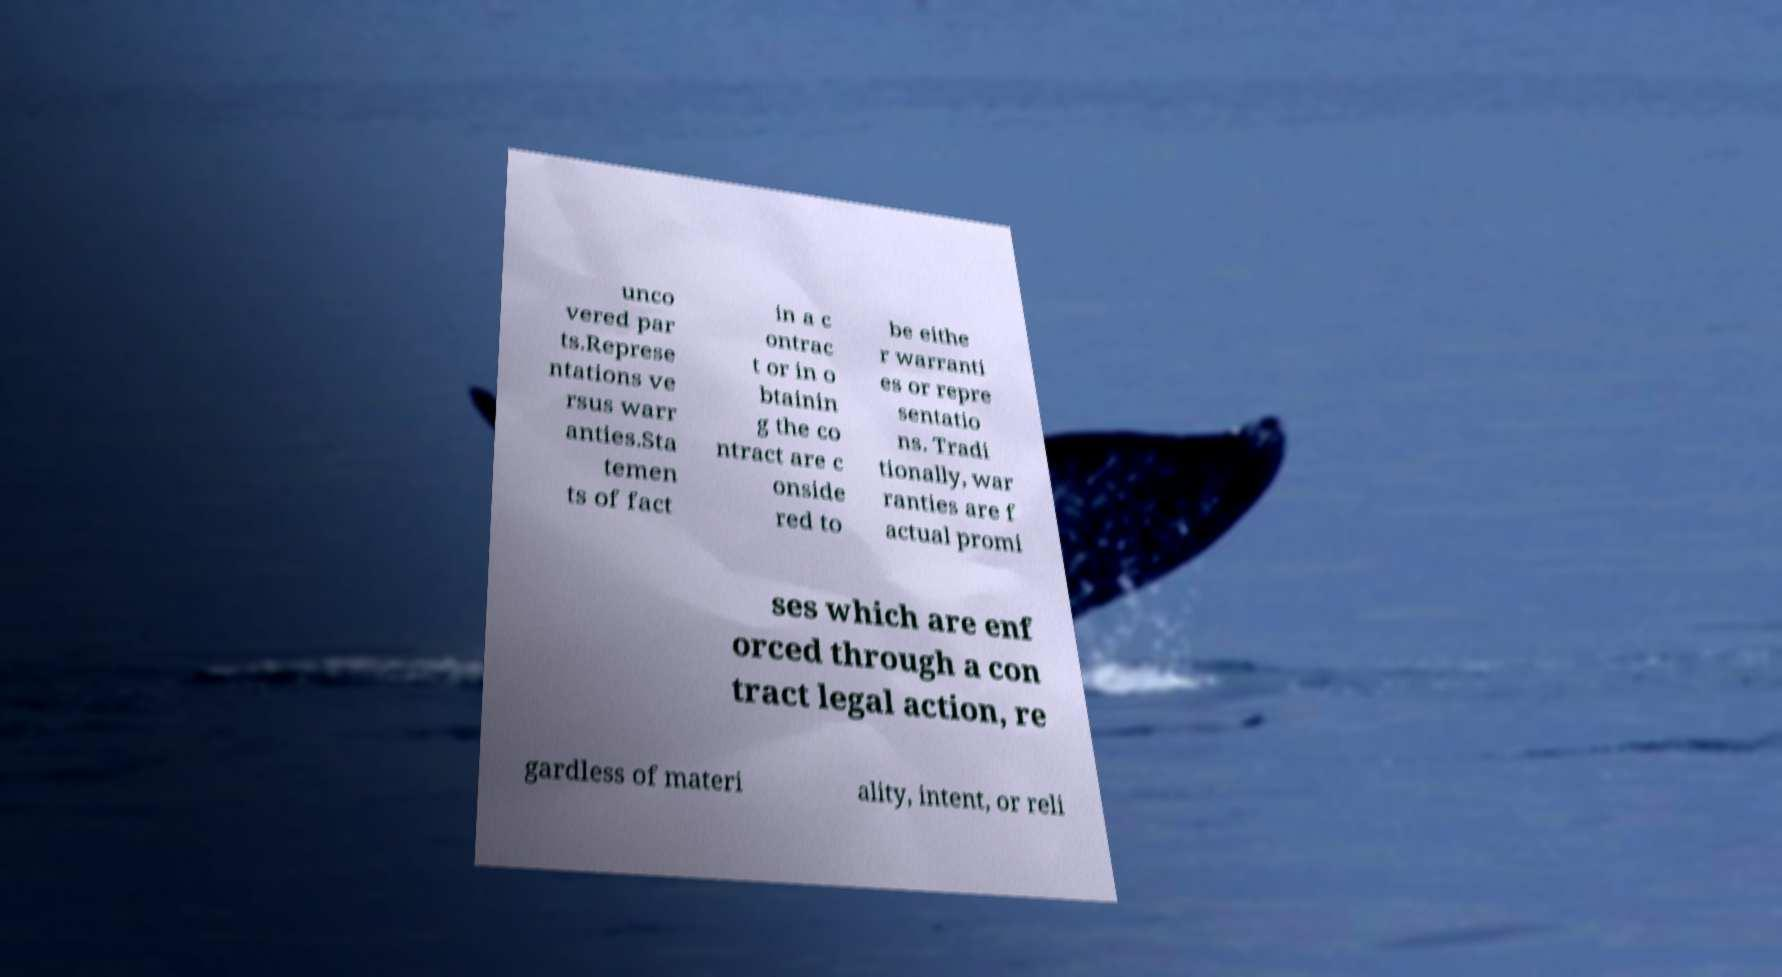What messages or text are displayed in this image? I need them in a readable, typed format. unco vered par ts.Represe ntations ve rsus warr anties.Sta temen ts of fact in a c ontrac t or in o btainin g the co ntract are c onside red to be eithe r warranti es or repre sentatio ns. Tradi tionally, war ranties are f actual promi ses which are enf orced through a con tract legal action, re gardless of materi ality, intent, or reli 